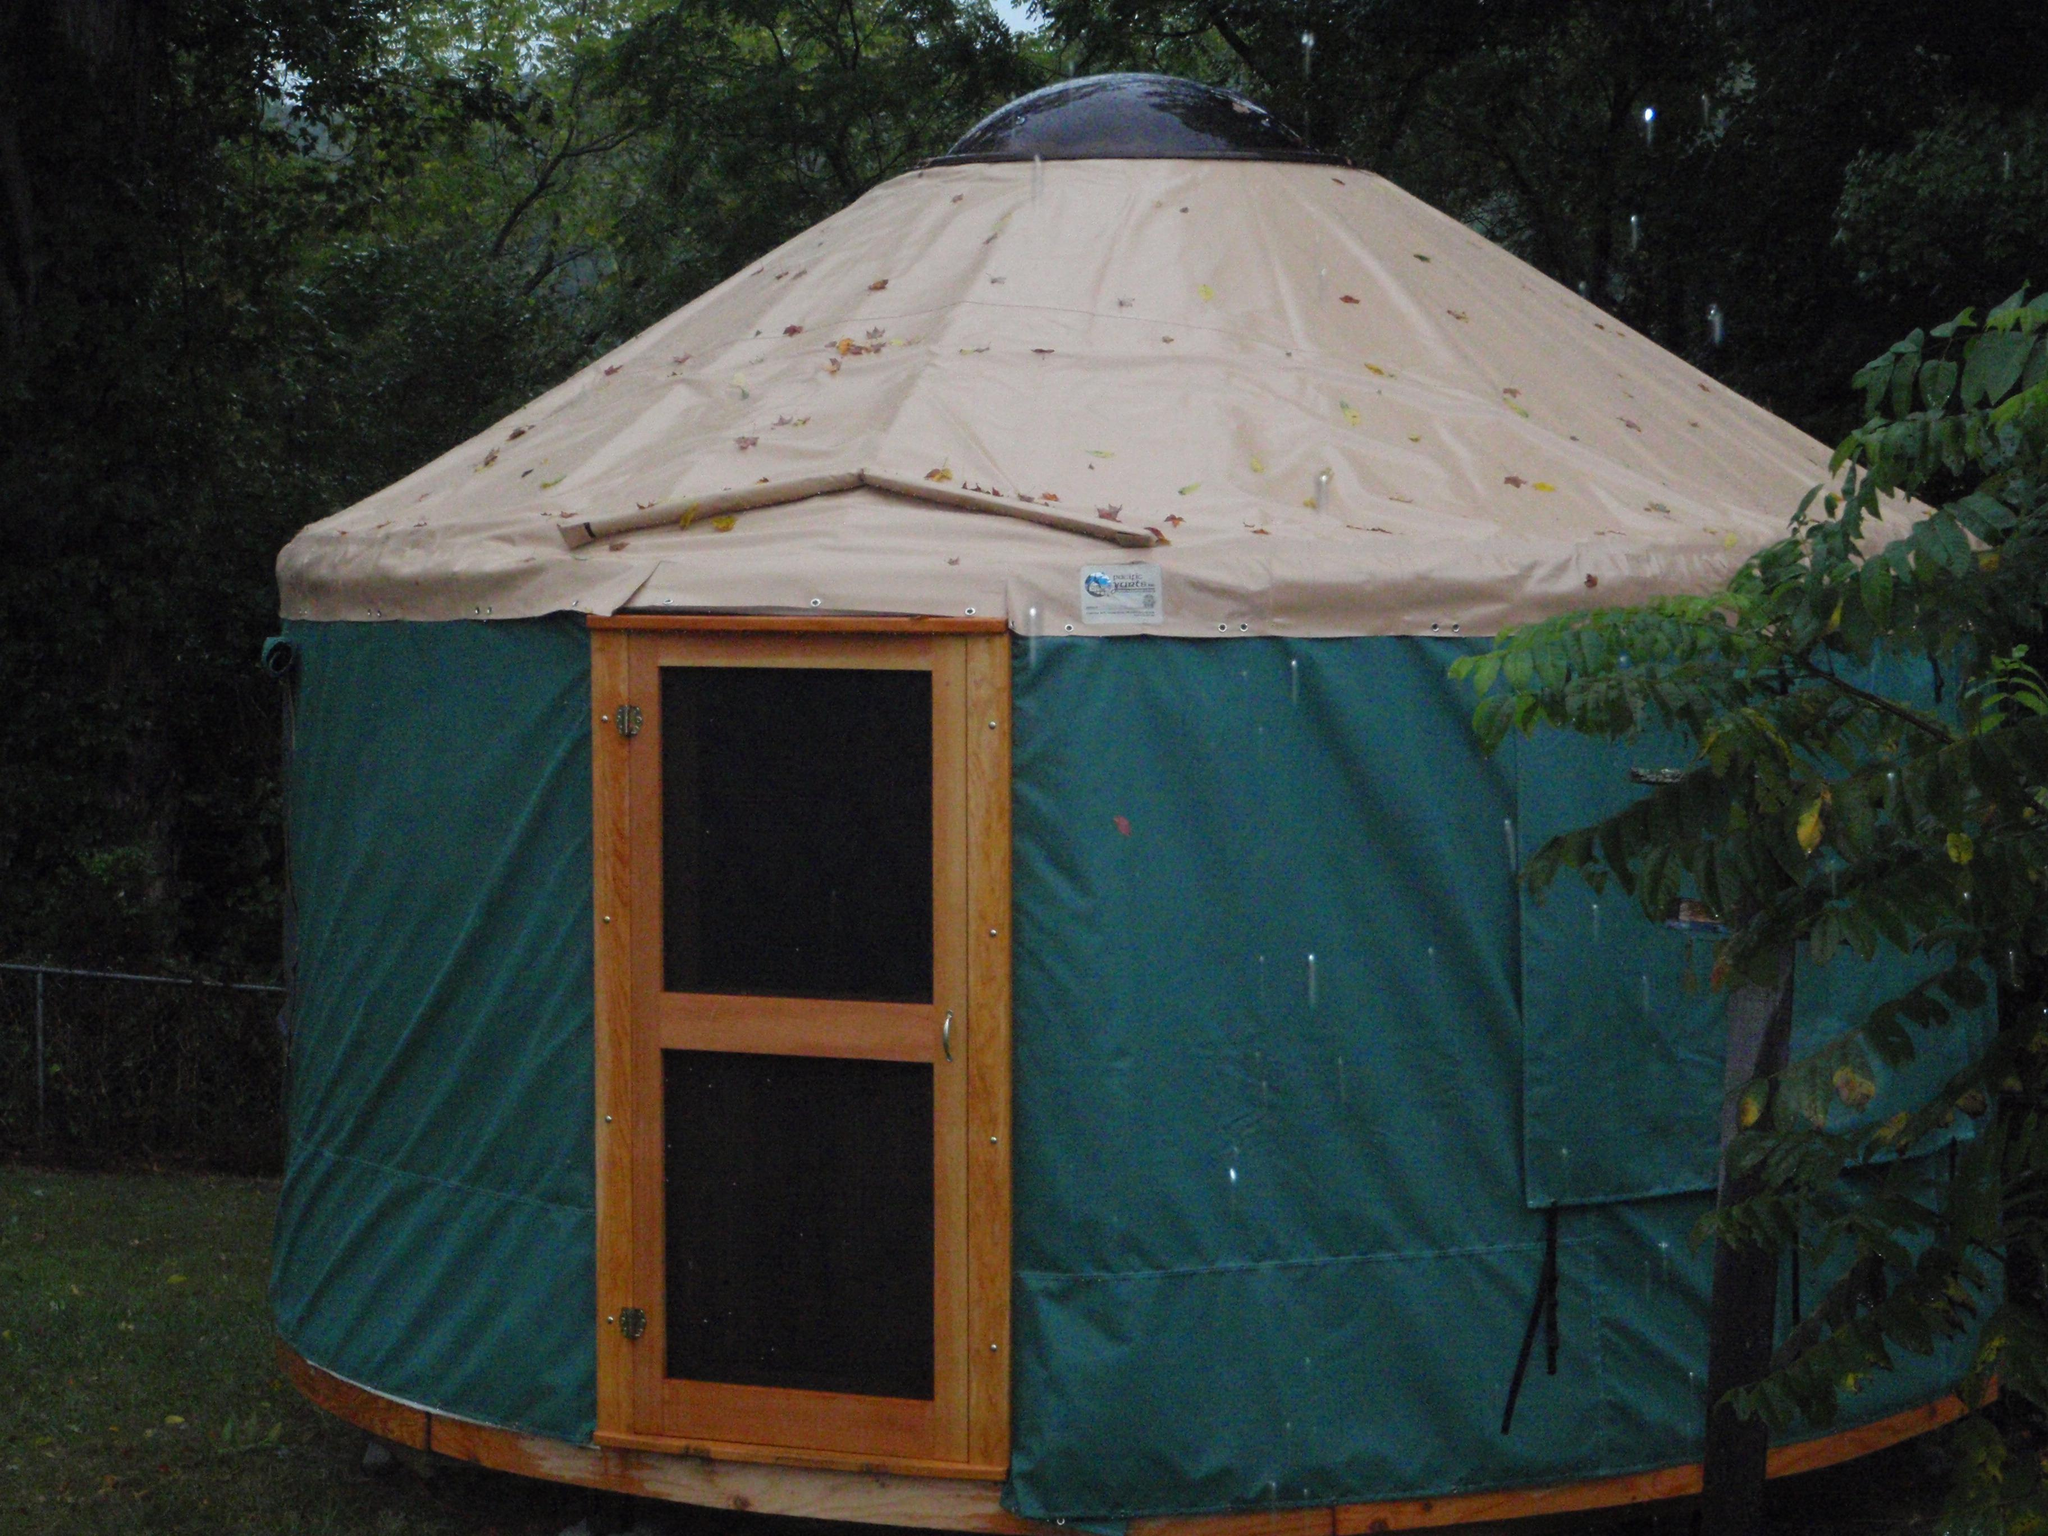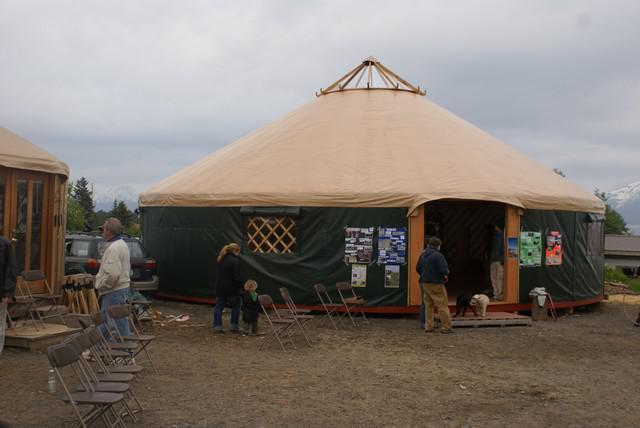The first image is the image on the left, the second image is the image on the right. Given the left and right images, does the statement "Multiple people are visible outside one of the tents/yurts." hold true? Answer yes or no. Yes. The first image is the image on the left, the second image is the image on the right. Evaluate the accuracy of this statement regarding the images: "All of the roofs are visible and tan". Is it true? Answer yes or no. Yes. 